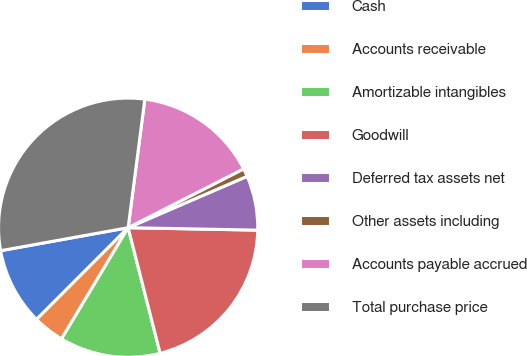Convert chart. <chart><loc_0><loc_0><loc_500><loc_500><pie_chart><fcel>Cash<fcel>Accounts receivable<fcel>Amortizable intangibles<fcel>Goodwill<fcel>Deferred tax assets net<fcel>Other assets including<fcel>Accounts payable accrued<fcel>Total purchase price<nl><fcel>9.67%<fcel>3.9%<fcel>12.56%<fcel>20.73%<fcel>6.79%<fcel>1.01%<fcel>15.45%<fcel>29.9%<nl></chart> 